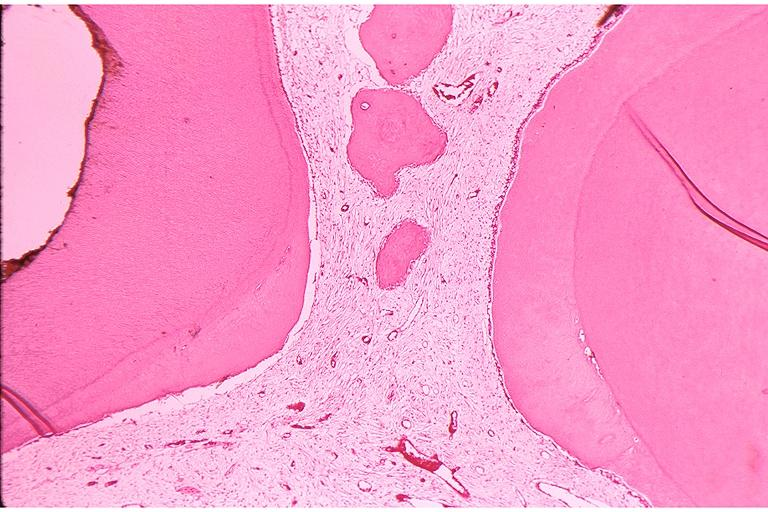s oral present?
Answer the question using a single word or phrase. Yes 